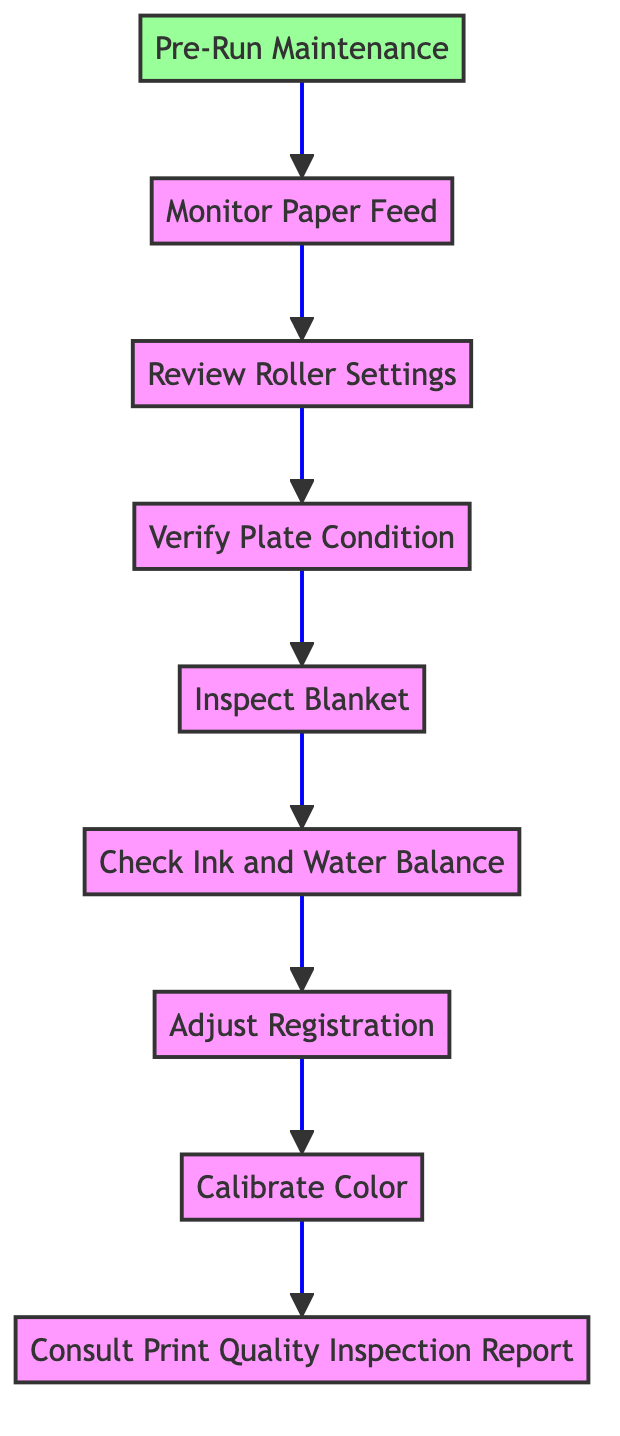What's the first step in the flow chart? The first step in the flow chart, which is at the bottom, is "Pre-Run Maintenance." This is indicated as the initial action that triggers the subsequent process.
Answer: Pre-Run Maintenance How many nodes are there in the diagram? By counting each unique action from "Pre-Run Maintenance" to "Consult Print Quality Inspection Report," there are a total of nine nodes in the flow chart.
Answer: Nine What comes immediately after "Monitor Paper Feed"? After "Monitor Paper Feed," the next step is "Review Roller Settings," which is directly connected in the flow of the chart, indicating the sequence of actions.
Answer: Review Roller Settings Which step follows "Calibrate Color"? Following "Calibrate Color," the next step is "Consult Print Quality Inspection Report." This shows the progression of troubleshooting quality issues in offset printing.
Answer: Consult Print Quality Inspection Report What is the relationship between "Check Ink and Water Balance" and "Inspect Blanket"? "Check Ink and Water Balance" proceeds directly before "Inspect Blanket" in the flow chart. This indicates that checking ink and water balance is a step that needs to be completed prior to inspecting the blanket.
Answer: Sequential relationship What is the last step in the troubleshooting process? The last step in this troubleshooting process, as indicated at the top of the flow chart, is "Consult Print Quality Inspection Report." This encapsulates the final action taken after all troubleshooting steps have been completed.
Answer: Consult Print Quality Inspection Report What node describes a maintenance task? The node that describes a maintenance task is "Pre-Run Maintenance." This task involves conducting routine maintenance like lubrication and cleaning to prepare the machine for operation.
Answer: Pre-Run Maintenance How would you describe the overall flow of the chart? The overall flow of the chart is sequential, where each step logically follows the previous one, leading from initial maintenance to final inspection report consultation, establishing a clear pathway for troubleshooting.
Answer: Sequential flow 